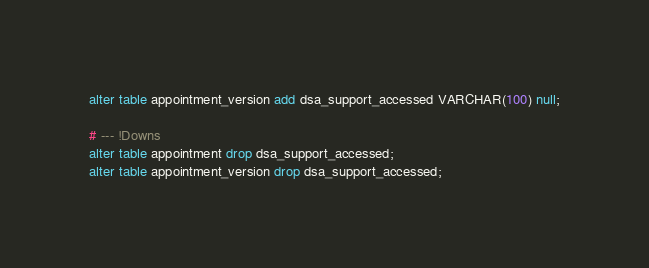Convert code to text. <code><loc_0><loc_0><loc_500><loc_500><_SQL_>alter table appointment_version add dsa_support_accessed VARCHAR(100) null;

# --- !Downs
alter table appointment drop dsa_support_accessed;
alter table appointment_version drop dsa_support_accessed;
</code> 